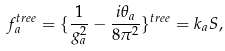<formula> <loc_0><loc_0><loc_500><loc_500>f _ { a } ^ { t r e e } = \{ \frac { 1 } { g _ { a } ^ { 2 } } - \frac { i \theta _ { a } } { 8 \pi ^ { 2 } } \} ^ { t r e e } = k _ { a } S ,</formula> 